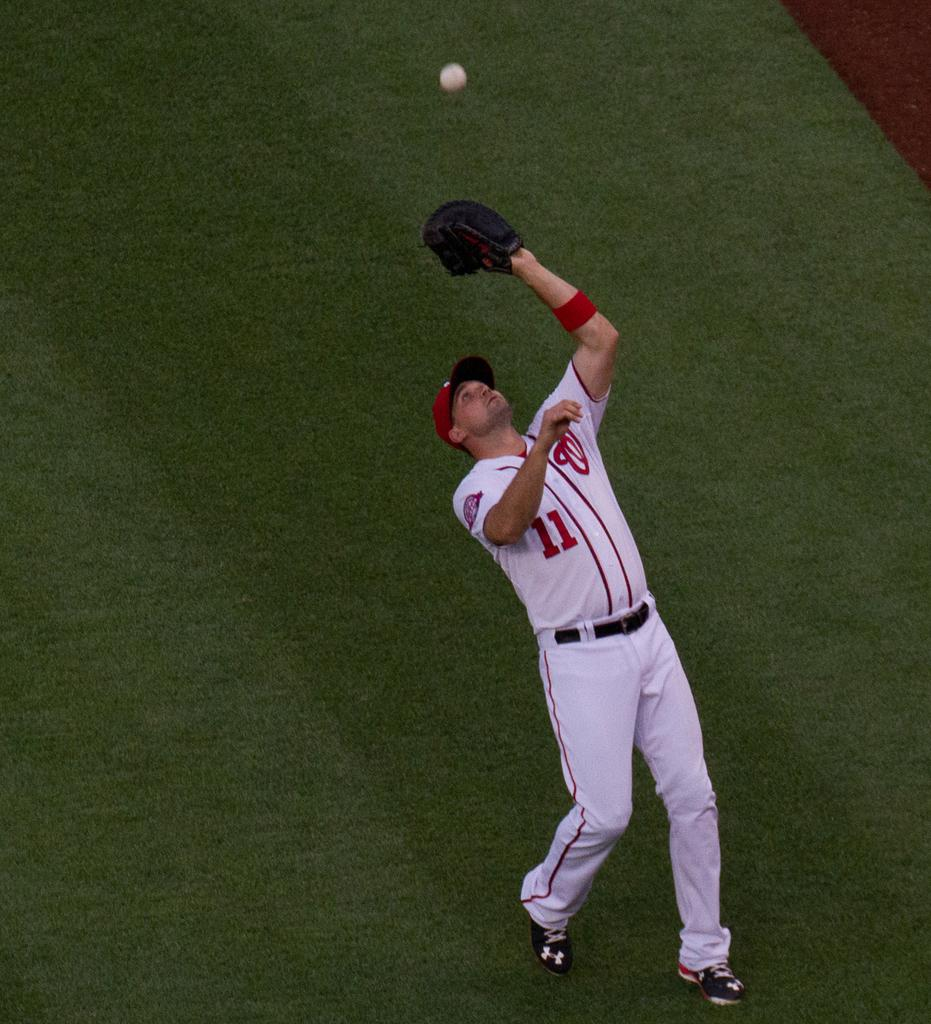<image>
Share a concise interpretation of the image provided. A baseball player wearing number eleven is about to catch the ball. 